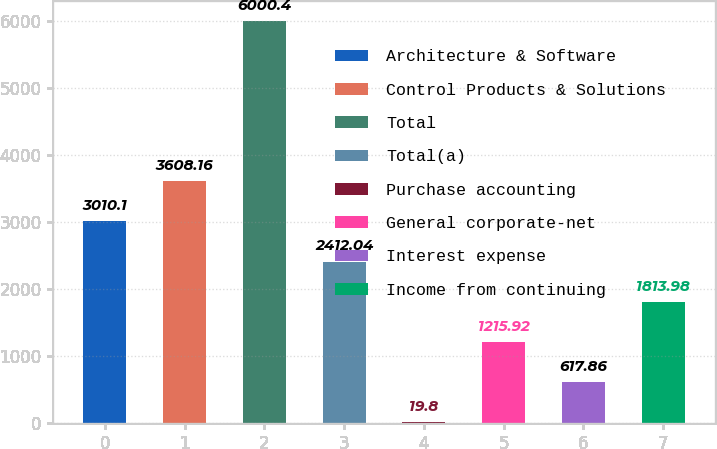Convert chart. <chart><loc_0><loc_0><loc_500><loc_500><bar_chart><fcel>Architecture & Software<fcel>Control Products & Solutions<fcel>Total<fcel>Total(a)<fcel>Purchase accounting<fcel>General corporate-net<fcel>Interest expense<fcel>Income from continuing<nl><fcel>3010.1<fcel>3608.16<fcel>6000.4<fcel>2412.04<fcel>19.8<fcel>1215.92<fcel>617.86<fcel>1813.98<nl></chart> 